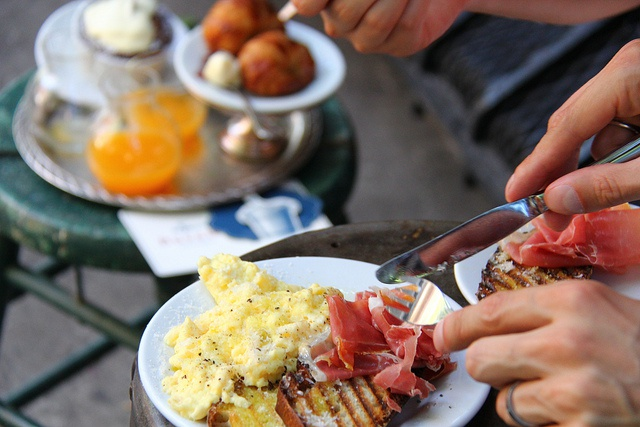Describe the objects in this image and their specific colors. I can see people in gray, brown, tan, salmon, and maroon tones, bowl in gray, maroon, lightgray, darkgray, and brown tones, cup in gray, orange, darkgray, and tan tones, people in gray, maroon, and brown tones, and knife in gray, maroon, black, and brown tones in this image. 